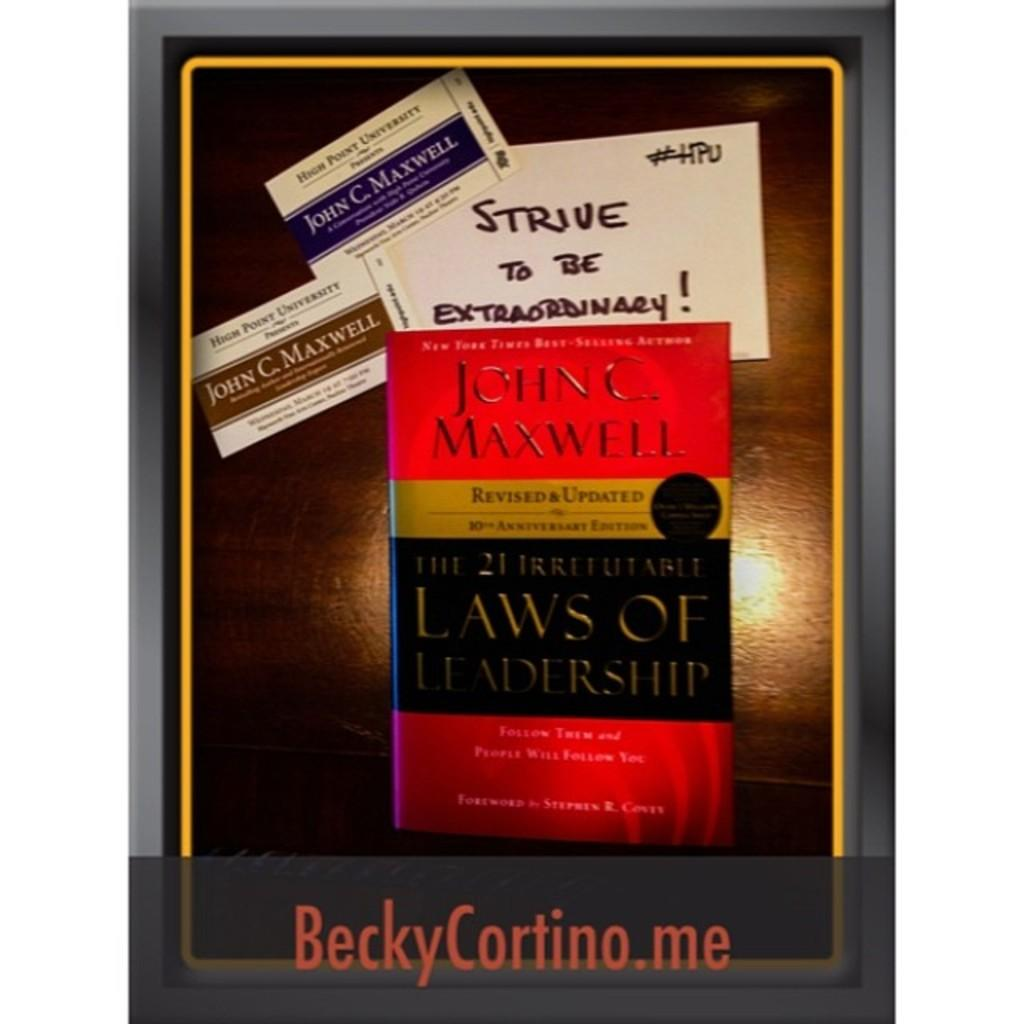<image>
Share a concise interpretation of the image provided. A sign shows author John C Maxwell is having an event at High Point University. 